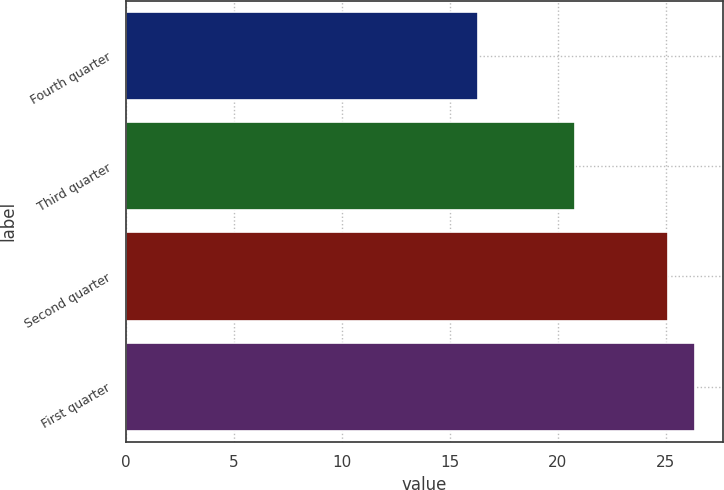Convert chart to OTSL. <chart><loc_0><loc_0><loc_500><loc_500><bar_chart><fcel>Fourth quarter<fcel>Third quarter<fcel>Second quarter<fcel>First quarter<nl><fcel>16.28<fcel>20.8<fcel>25.11<fcel>26.34<nl></chart> 